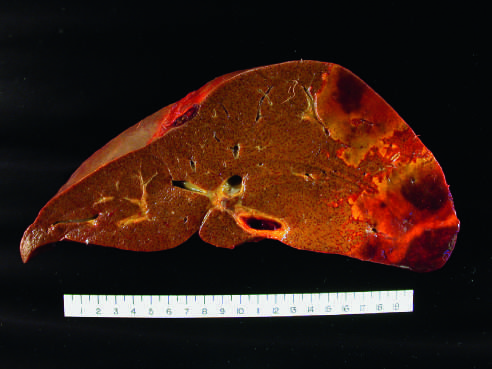how is the distal hepatic tissue?
Answer the question using a single word or phrase. Pale 